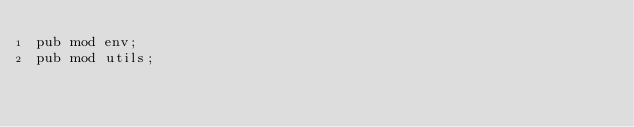<code> <loc_0><loc_0><loc_500><loc_500><_Rust_>pub mod env;
pub mod utils;
</code> 